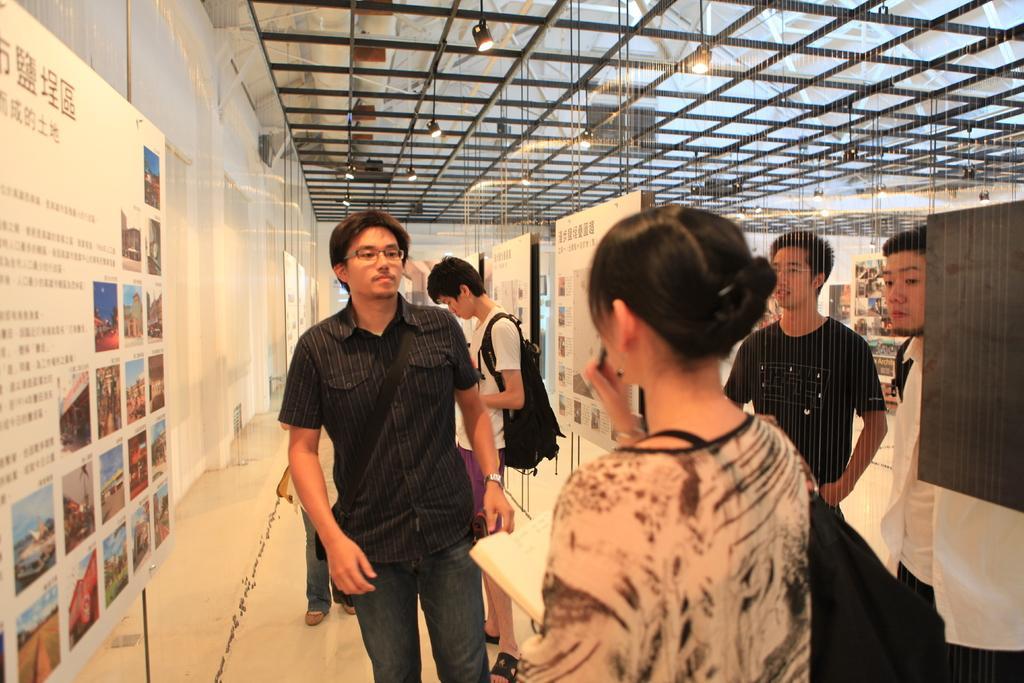Can you describe this image briefly? As we can see in the image there is a wall, banner, few people here and there. The woman in the front is holding a book and the person over here is wearing a black color bag. 